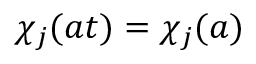Convert formula to latex. <formula><loc_0><loc_0><loc_500><loc_500>\chi _ { j } ( a t ) = \chi _ { j } ( a )</formula> 